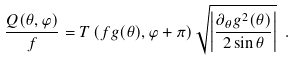<formula> <loc_0><loc_0><loc_500><loc_500>\frac { Q ( \theta , \varphi ) } { f } = T \left ( f g ( \theta ) , \varphi + \pi \right ) \sqrt { \left | \frac { \partial _ { \theta } g ^ { 2 } ( \theta ) } { 2 \sin \theta } \right | } \ .</formula> 